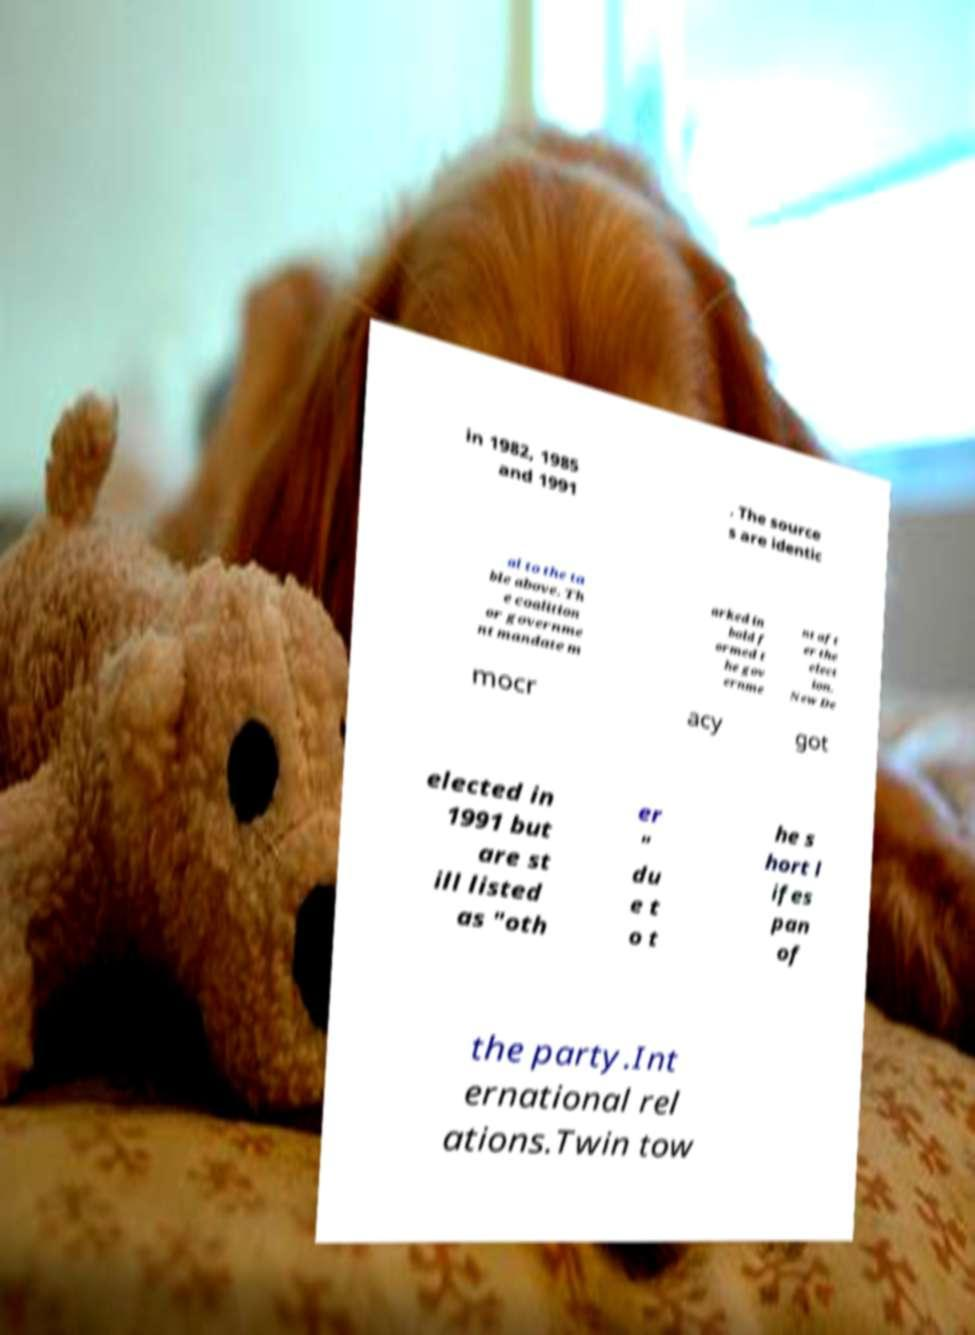For documentation purposes, I need the text within this image transcribed. Could you provide that? in 1982, 1985 and 1991 . The source s are identic al to the ta ble above. Th e coalition or governme nt mandate m arked in bold f ormed t he gov ernme nt aft er the elect ion. New De mocr acy got elected in 1991 but are st ill listed as "oth er " du e t o t he s hort l ifes pan of the party.Int ernational rel ations.Twin tow 